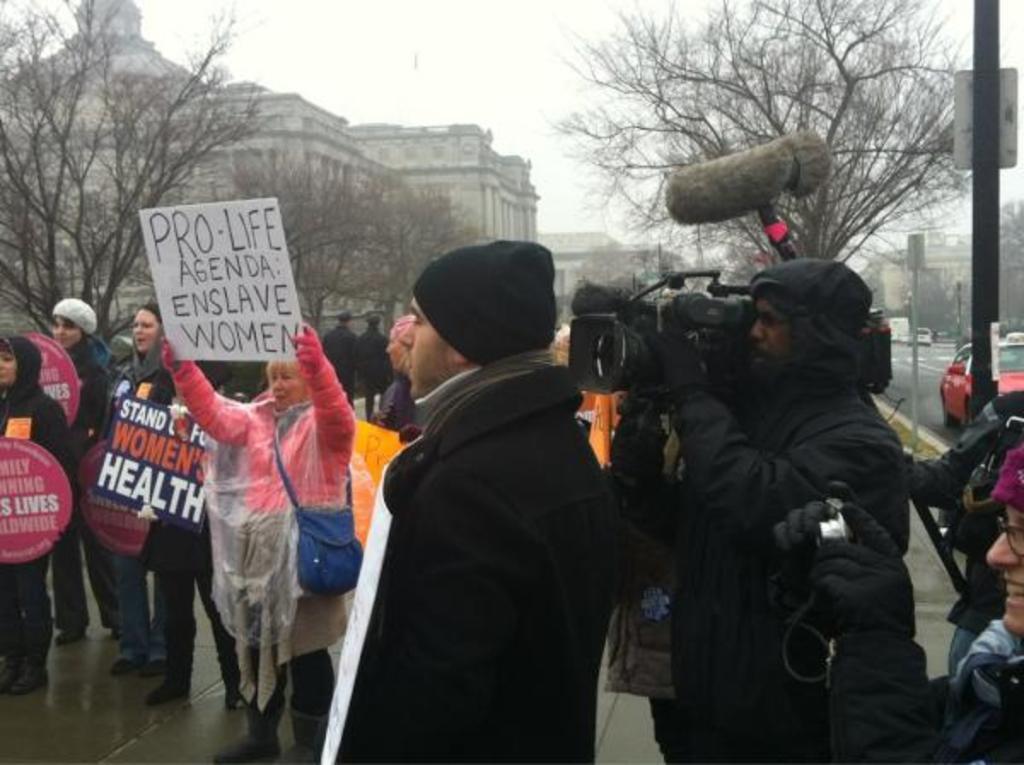Describe this image in one or two sentences. In this picture we can see few people, among them few are holding boards, behind we can see some tree, buildings, right side of the image we can see some vehicles moving on the roof. 